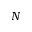<formula> <loc_0><loc_0><loc_500><loc_500>N</formula> 